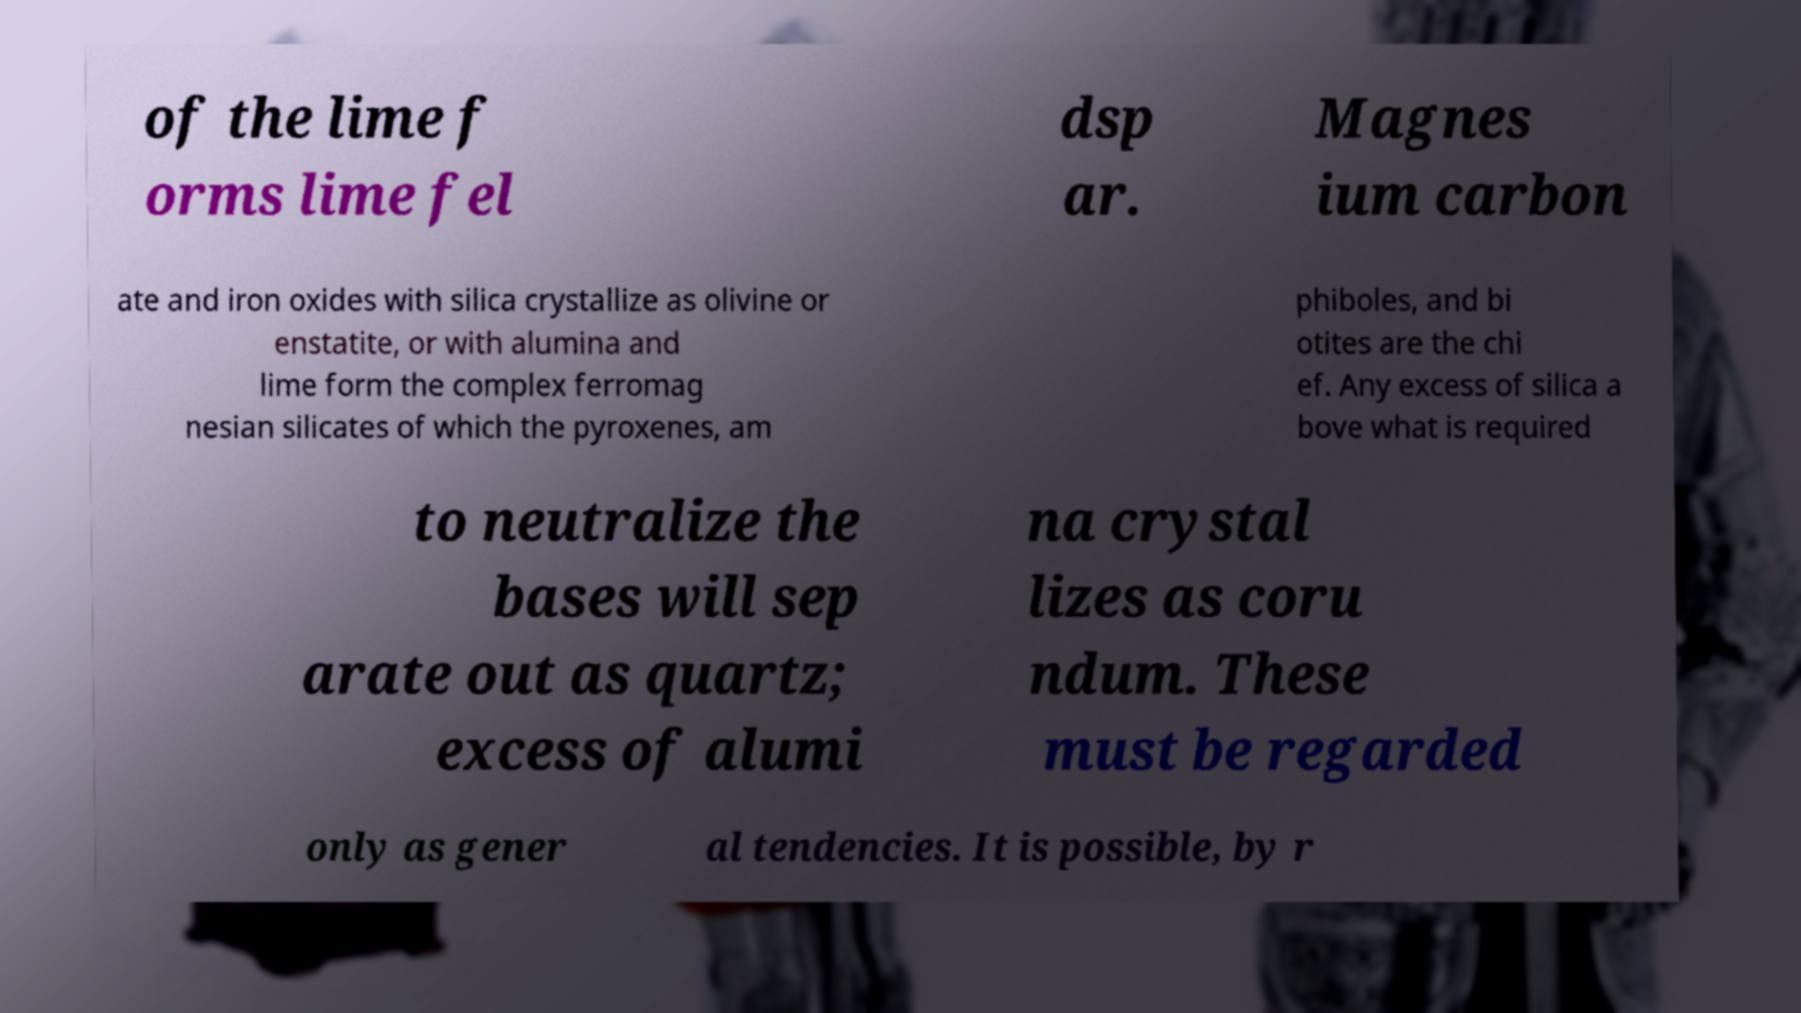Please read and relay the text visible in this image. What does it say? of the lime f orms lime fel dsp ar. Magnes ium carbon ate and iron oxides with silica crystallize as olivine or enstatite, or with alumina and lime form the complex ferromag nesian silicates of which the pyroxenes, am phiboles, and bi otites are the chi ef. Any excess of silica a bove what is required to neutralize the bases will sep arate out as quartz; excess of alumi na crystal lizes as coru ndum. These must be regarded only as gener al tendencies. It is possible, by r 